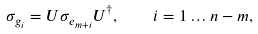Convert formula to latex. <formula><loc_0><loc_0><loc_500><loc_500>\sigma _ { g _ { i } } = U \sigma _ { e _ { m + i } } U ^ { \dag } , \quad i = 1 \dots n - m ,</formula> 